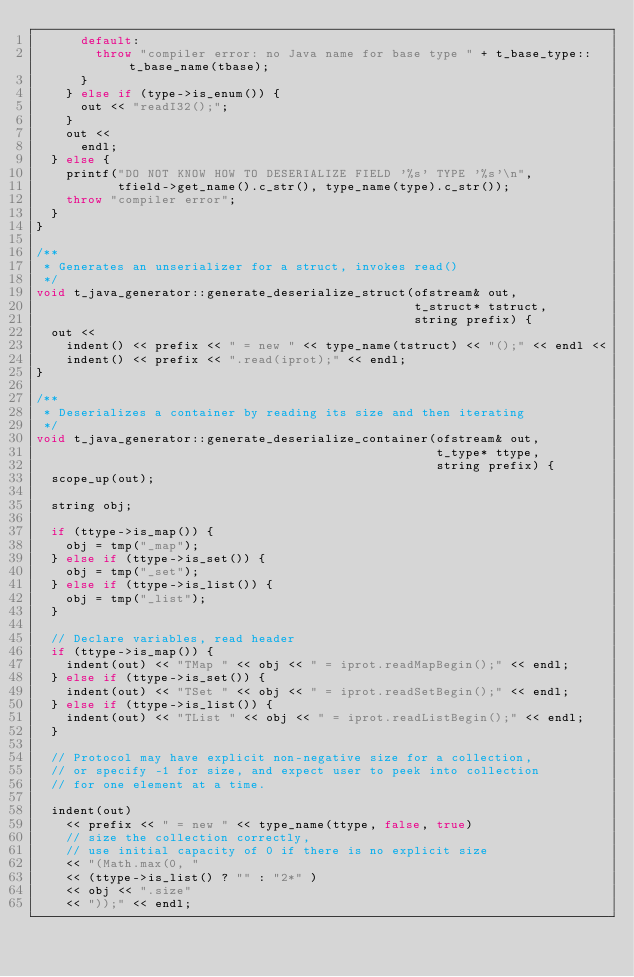Convert code to text. <code><loc_0><loc_0><loc_500><loc_500><_C++_>      default:
        throw "compiler error: no Java name for base type " + t_base_type::t_base_name(tbase);
      }
    } else if (type->is_enum()) {
      out << "readI32();";
    }
    out <<
      endl;
  } else {
    printf("DO NOT KNOW HOW TO DESERIALIZE FIELD '%s' TYPE '%s'\n",
           tfield->get_name().c_str(), type_name(type).c_str());
    throw "compiler error";
  }
}

/**
 * Generates an unserializer for a struct, invokes read()
 */
void t_java_generator::generate_deserialize_struct(ofstream& out,
                                                   t_struct* tstruct,
                                                   string prefix) {
  out <<
    indent() << prefix << " = new " << type_name(tstruct) << "();" << endl <<
    indent() << prefix << ".read(iprot);" << endl;
}

/**
 * Deserializes a container by reading its size and then iterating
 */
void t_java_generator::generate_deserialize_container(ofstream& out,
                                                      t_type* ttype,
                                                      string prefix) {
  scope_up(out);

  string obj;

  if (ttype->is_map()) {
    obj = tmp("_map");
  } else if (ttype->is_set()) {
    obj = tmp("_set");
  } else if (ttype->is_list()) {
    obj = tmp("_list");
  }

  // Declare variables, read header
  if (ttype->is_map()) {
    indent(out) << "TMap " << obj << " = iprot.readMapBegin();" << endl;
  } else if (ttype->is_set()) {
    indent(out) << "TSet " << obj << " = iprot.readSetBegin();" << endl;
  } else if (ttype->is_list()) {
    indent(out) << "TList " << obj << " = iprot.readListBegin();" << endl;
  }

  // Protocol may have explicit non-negative size for a collection,
  // or specify -1 for size, and expect user to peek into collection
  // for one element at a time.

  indent(out)
    << prefix << " = new " << type_name(ttype, false, true)
    // size the collection correctly,
    // use initial capacity of 0 if there is no explicit size
    << "(Math.max(0, "
    << (ttype->is_list() ? "" : "2*" )
    << obj << ".size"
    << "));" << endl;
</code> 